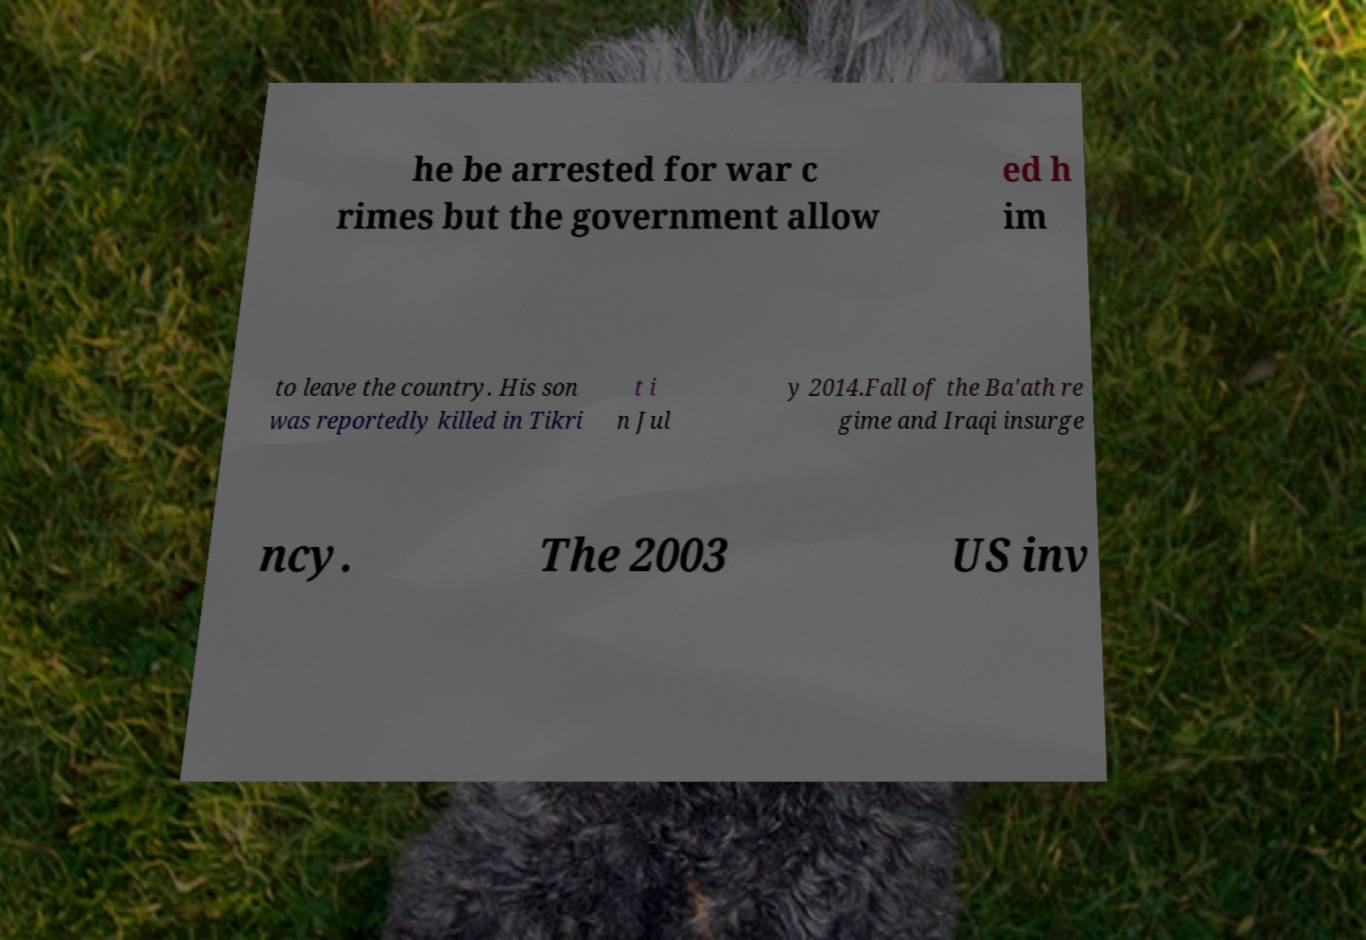Please identify and transcribe the text found in this image. he be arrested for war c rimes but the government allow ed h im to leave the country. His son was reportedly killed in Tikri t i n Jul y 2014.Fall of the Ba'ath re gime and Iraqi insurge ncy. The 2003 US inv 